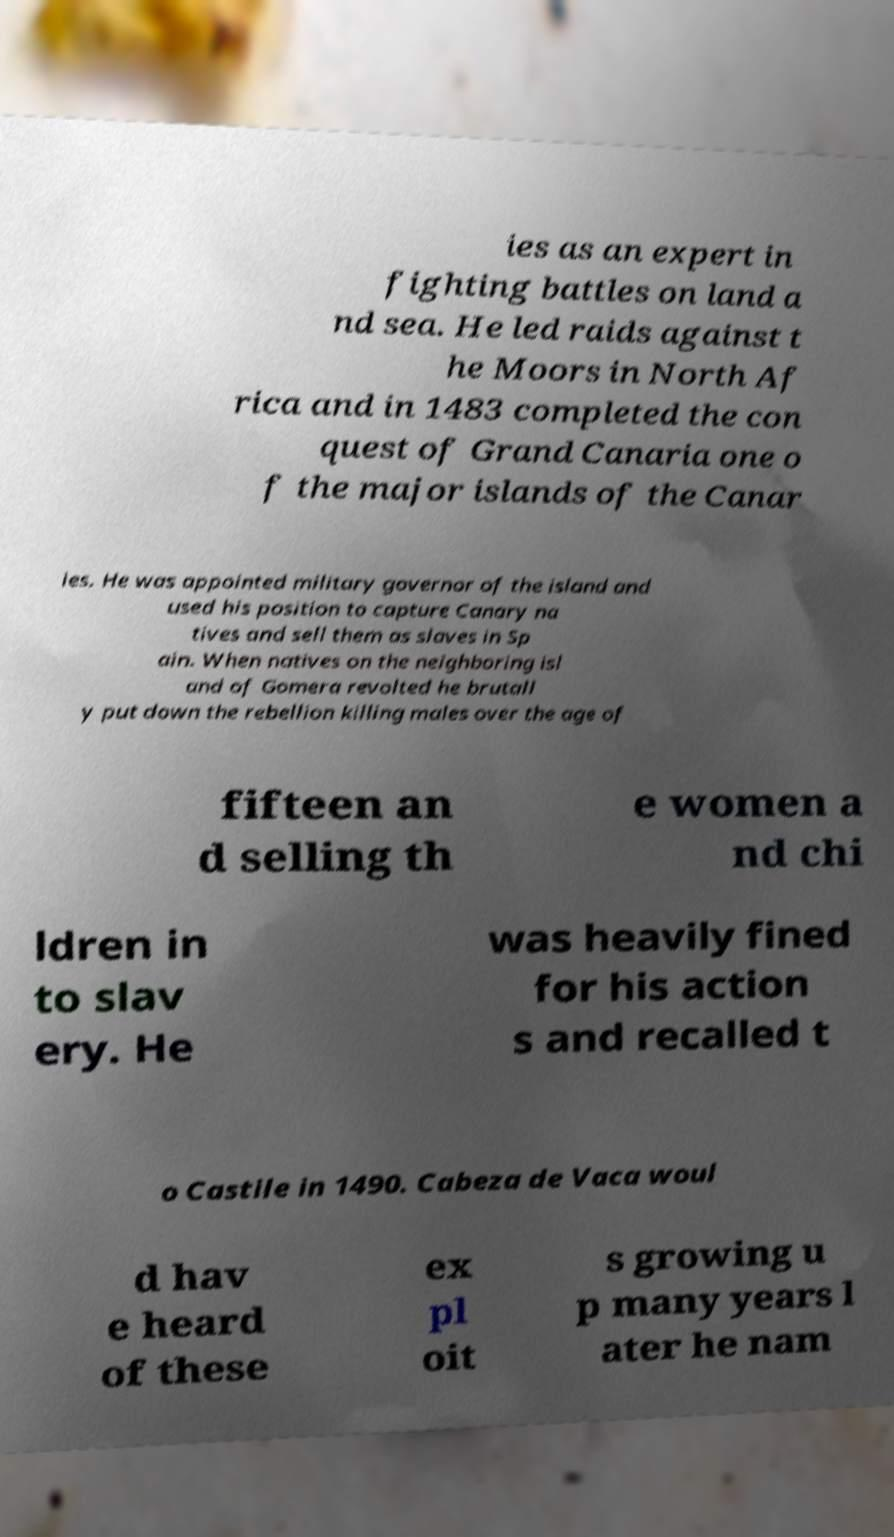Can you read and provide the text displayed in the image?This photo seems to have some interesting text. Can you extract and type it out for me? ies as an expert in fighting battles on land a nd sea. He led raids against t he Moors in North Af rica and in 1483 completed the con quest of Grand Canaria one o f the major islands of the Canar ies. He was appointed military governor of the island and used his position to capture Canary na tives and sell them as slaves in Sp ain. When natives on the neighboring isl and of Gomera revolted he brutall y put down the rebellion killing males over the age of fifteen an d selling th e women a nd chi ldren in to slav ery. He was heavily fined for his action s and recalled t o Castile in 1490. Cabeza de Vaca woul d hav e heard of these ex pl oit s growing u p many years l ater he nam 